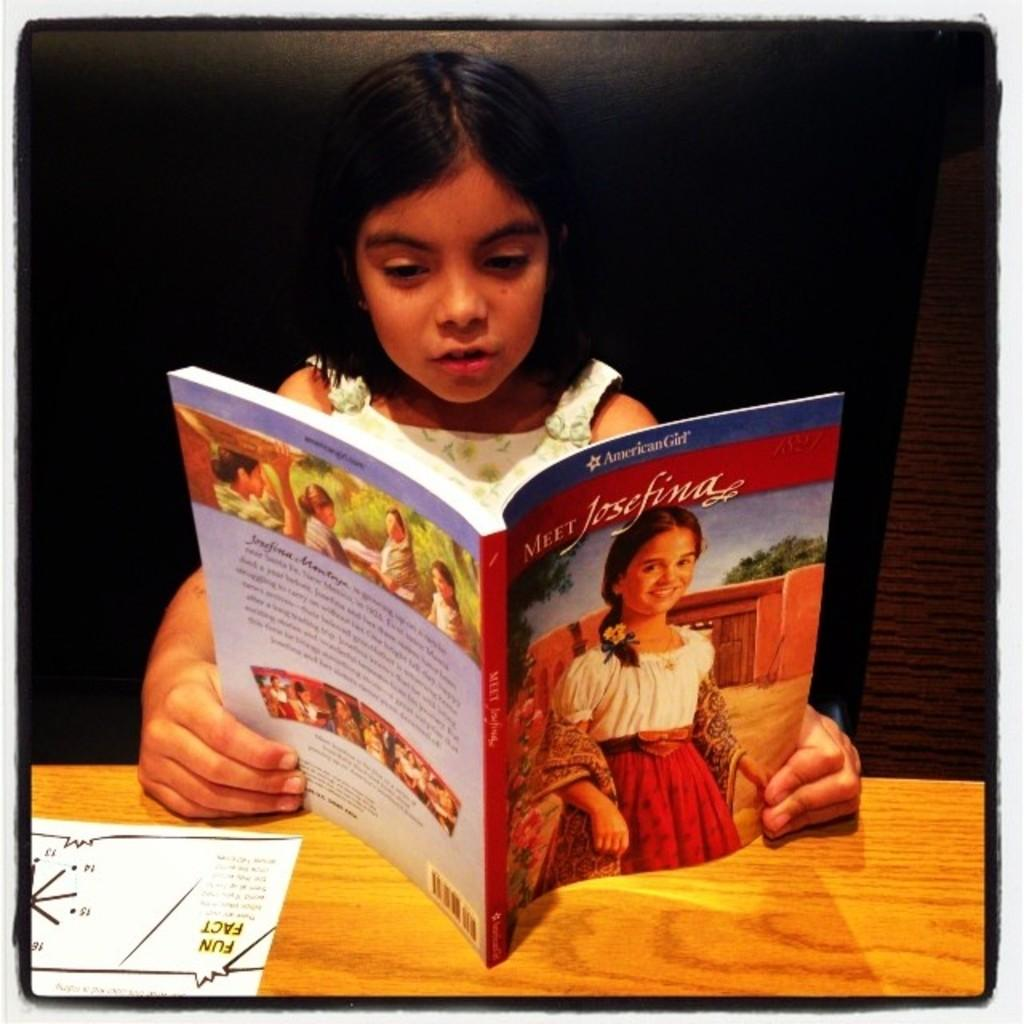<image>
Describe the image concisely. A girl sitting at a table reading the book "Meet Josephina". 